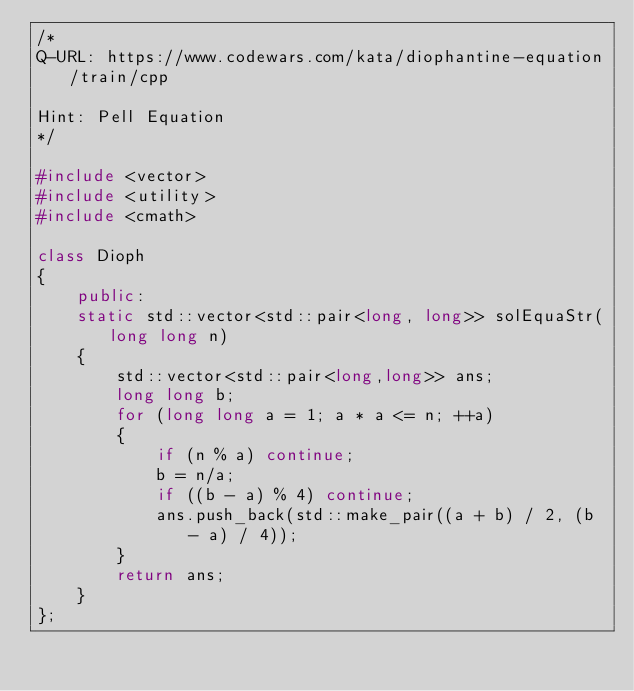Convert code to text. <code><loc_0><loc_0><loc_500><loc_500><_C++_>/*
Q-URL: https://www.codewars.com/kata/diophantine-equation/train/cpp

Hint: Pell Equation
*/

#include <vector>
#include <utility>
#include <cmath>

class Dioph
{
    public:
    static std::vector<std::pair<long, long>> solEquaStr(long long n)
    {
        std::vector<std::pair<long,long>> ans;
        long long b;
        for (long long a = 1; a * a <= n; ++a)
        {
            if (n % a) continue;
            b = n/a;
            if ((b - a) % 4) continue;
            ans.push_back(std::make_pair((a + b) / 2, (b - a) / 4));
        }
        return ans;
    }
};
</code> 